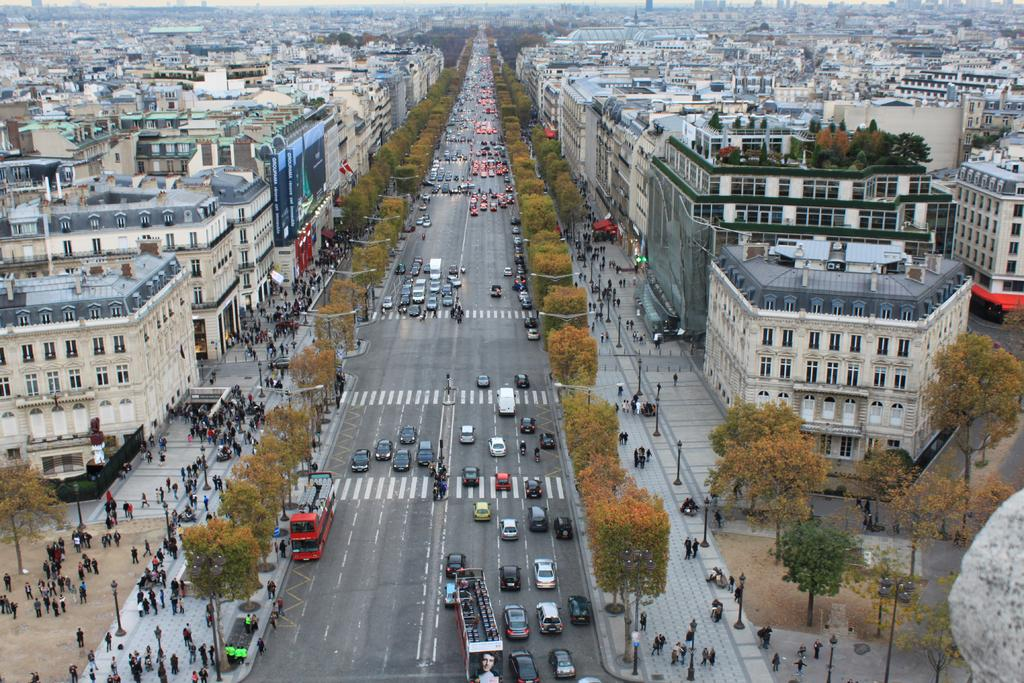What can be seen on the road in the image? There are vehicles on the road in the image. Who or what else is present in the image? There are people in the image. What type of natural elements can be seen in the image? There are trees in the image. What type of man-made structures are visible in the image? There are buildings in the image. What are the light sources on the road in the image? There are light poles in the image. What type of skate is being used by the people in the image? There is no skate present in the image; people are not using any skates. What type of tank can be seen in the image? There is no tank present in the image; it features vehicles on the road, people, trees, buildings, and light poles. --- Facts: 1. There is a person holding a book in the image. 2. The person is sitting on a chair. 3. There is a table in the image. 4. The table has a lamp on it. 5. There is a painting on the wall. Absurd Topics: parrot, trampoline, scent Conversation: What is the person in the image holding? The person in the image is holding a book. Where is the person sitting? The person is sitting on a chair. What is on the table in the image? There is a lamp on the table in the image. What is on the wall in the image? There is a painting on the wall in the image. Reasoning: Let's think step by step in order to produce the conversation. We start by identifying the main subject in the image, which is the person holding a book. Then, we describe the person's actions and the objects around them. We ensure that each question can be answered definitively with the information given. We avoid yes/no questions and ensure that the language is simple and clear. Absurd Question/Answer: What type of parrot can be seen sitting on the chair next to the person in the image? There is no parrot present in the image. --- Facts: 1. There is a person holding a book in the image. 2. The person is sitting on a chair. 3. There is a table in the image. 4. The table has a lamp on it. 5. There is a painting on the wall. Absurd Topics: kangaroo, trampoline, scent Conversation: What is the person in the image holding? The person in the image is holding a book. Where is the person sitting in the image? The person is sitting on a chair. What is on the table in the image? There is a lamp on the table in the image. What is on the wall in the image? There 